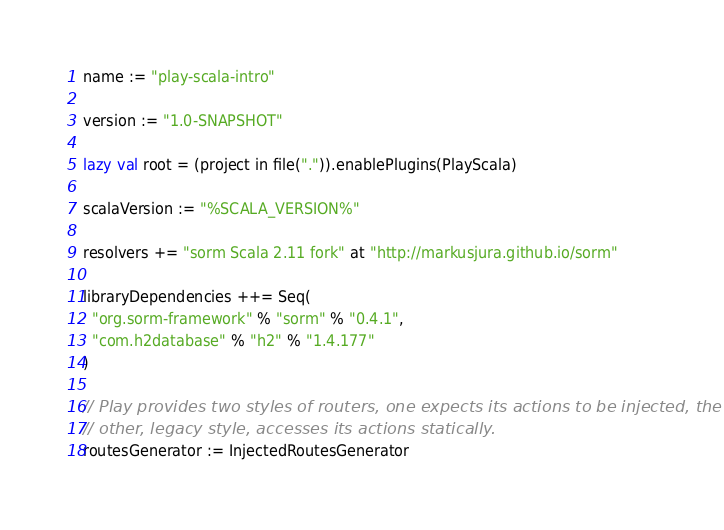Convert code to text. <code><loc_0><loc_0><loc_500><loc_500><_Scala_>name := "play-scala-intro"

version := "1.0-SNAPSHOT"

lazy val root = (project in file(".")).enablePlugins(PlayScala)

scalaVersion := "%SCALA_VERSION%"

resolvers += "sorm Scala 2.11 fork" at "http://markusjura.github.io/sorm"

libraryDependencies ++= Seq(  
  "org.sorm-framework" % "sorm" % "0.4.1",
  "com.h2database" % "h2" % "1.4.177"
)     

// Play provides two styles of routers, one expects its actions to be injected, the
// other, legacy style, accesses its actions statically.
routesGenerator := InjectedRoutesGenerator
</code> 